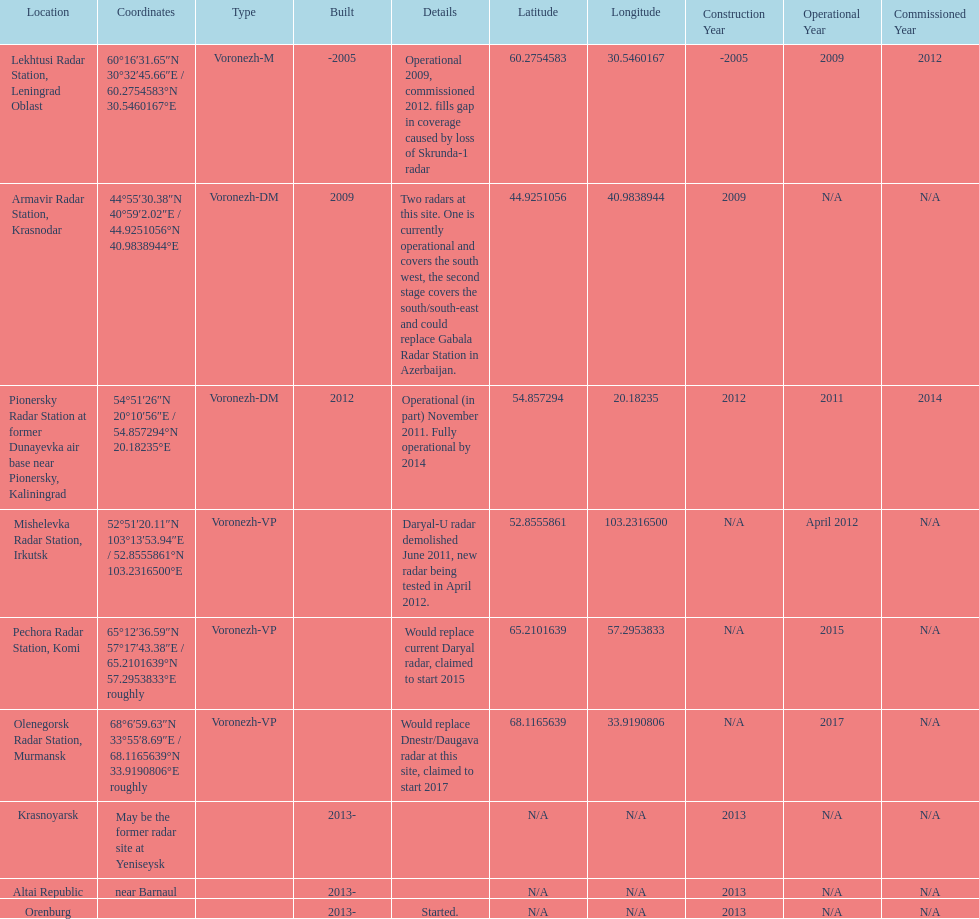Which site has the most radars? Armavir Radar Station, Krasnodar. 